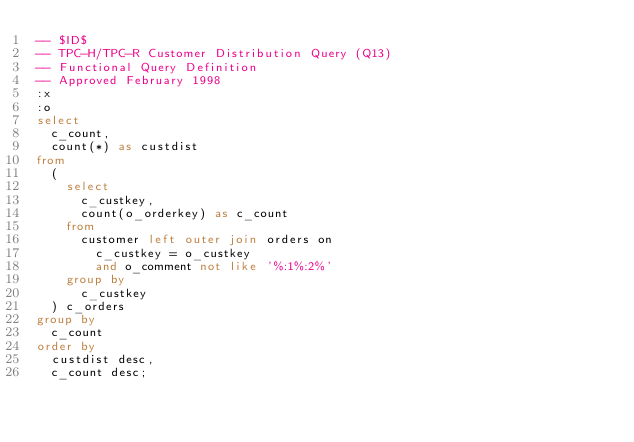<code> <loc_0><loc_0><loc_500><loc_500><_SQL_>-- $ID$
-- TPC-H/TPC-R Customer Distribution Query (Q13)
-- Functional Query Definition
-- Approved February 1998
:x
:o
select
	c_count,
	count(*) as custdist
from
	(
		select
			c_custkey,
			count(o_orderkey) as c_count
		from
			customer left outer join orders on
				c_custkey = o_custkey
				and o_comment not like '%:1%:2%'
		group by
			c_custkey
	) c_orders
group by
	c_count
order by
	custdist desc,
	c_count desc;
</code> 